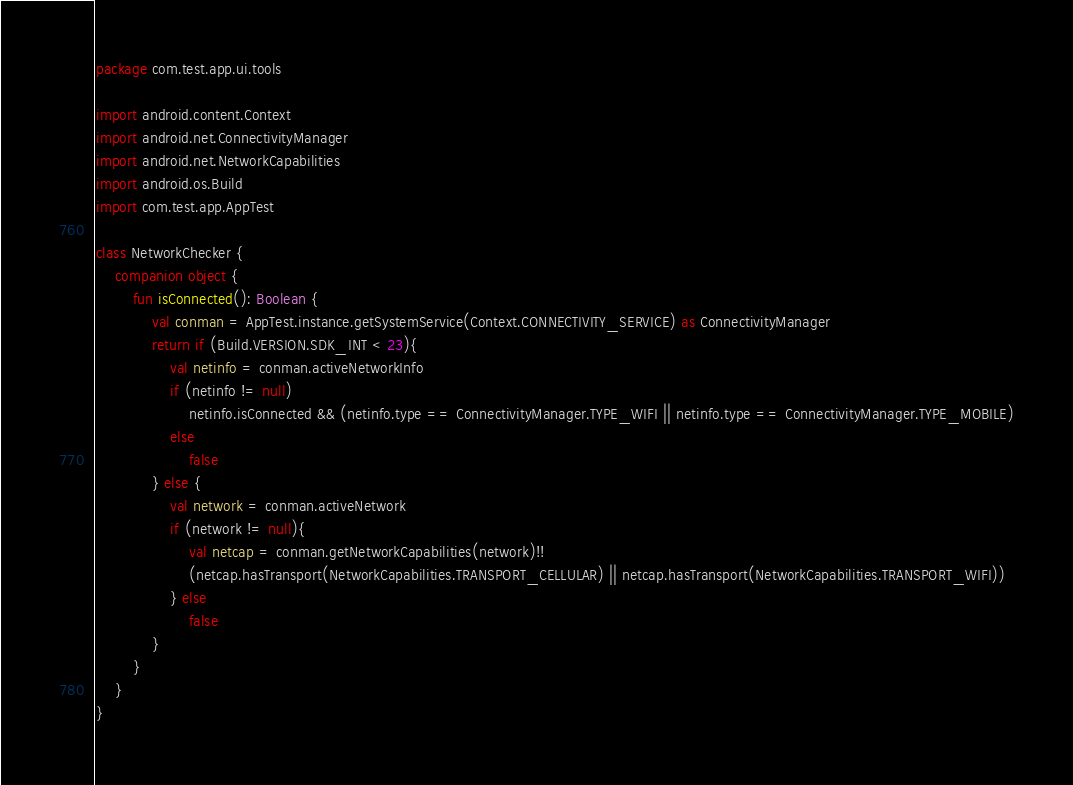<code> <loc_0><loc_0><loc_500><loc_500><_Kotlin_>package com.test.app.ui.tools

import android.content.Context
import android.net.ConnectivityManager
import android.net.NetworkCapabilities
import android.os.Build
import com.test.app.AppTest

class NetworkChecker {
    companion object {
        fun isConnected(): Boolean {
            val conman = AppTest.instance.getSystemService(Context.CONNECTIVITY_SERVICE) as ConnectivityManager
            return if (Build.VERSION.SDK_INT < 23){
                val netinfo = conman.activeNetworkInfo
                if (netinfo != null)
                    netinfo.isConnected && (netinfo.type == ConnectivityManager.TYPE_WIFI || netinfo.type == ConnectivityManager.TYPE_MOBILE)
                else
                    false
            } else {
                val network = conman.activeNetwork
                if (network != null){
                    val netcap = conman.getNetworkCapabilities(network)!!
                    (netcap.hasTransport(NetworkCapabilities.TRANSPORT_CELLULAR) || netcap.hasTransport(NetworkCapabilities.TRANSPORT_WIFI))
                } else
                    false
            }
        }
    }
}</code> 